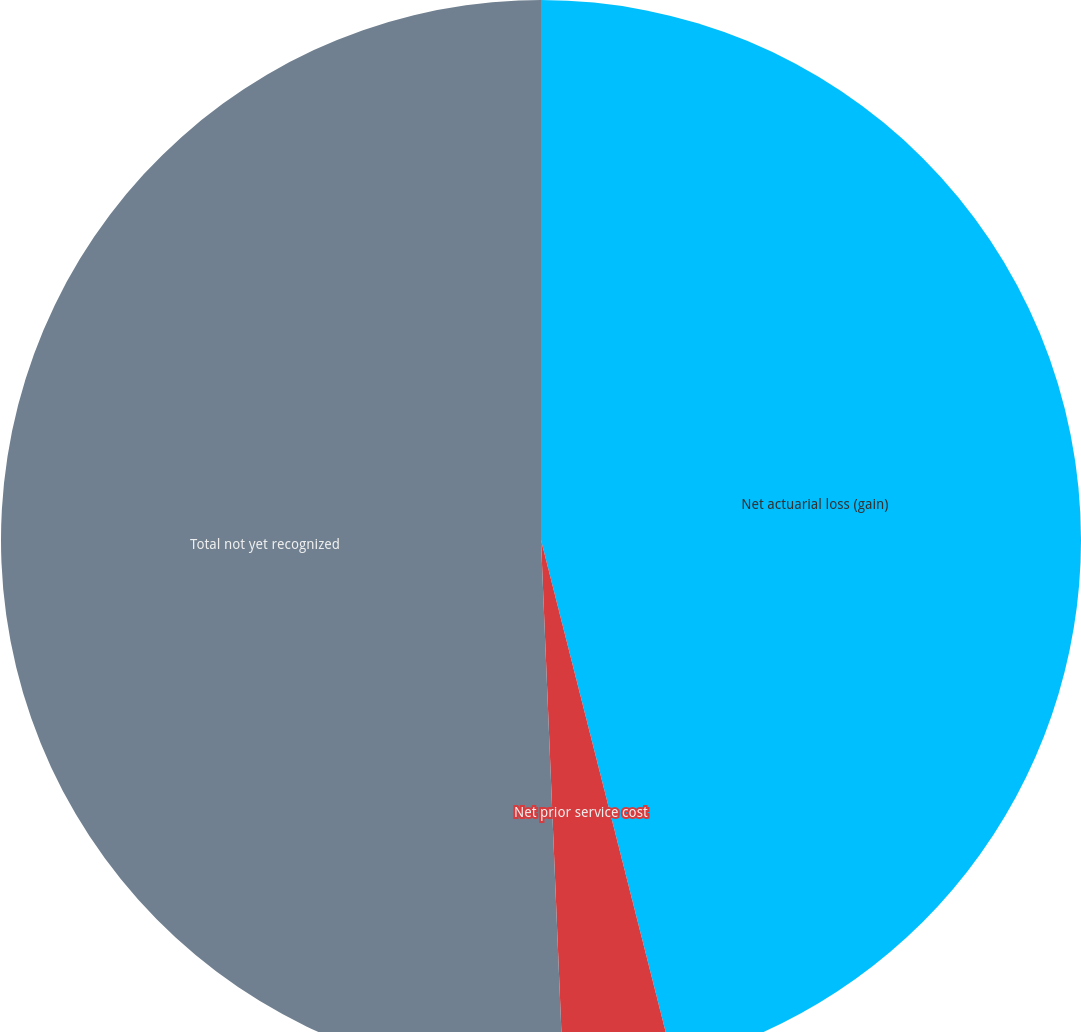Convert chart. <chart><loc_0><loc_0><loc_500><loc_500><pie_chart><fcel>Net actuarial loss (gain)<fcel>Net prior service cost<fcel>Total not yet recognized<nl><fcel>46.05%<fcel>3.29%<fcel>50.66%<nl></chart> 